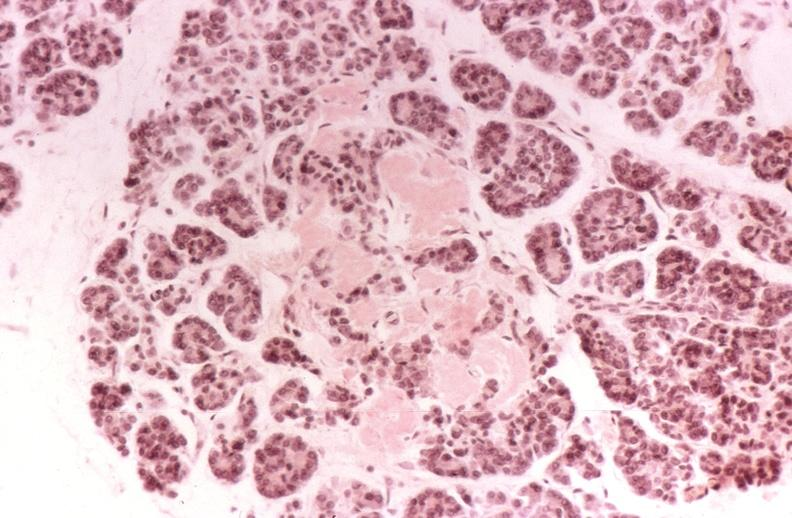what is present?
Answer the question using a single word or phrase. Pancreas 